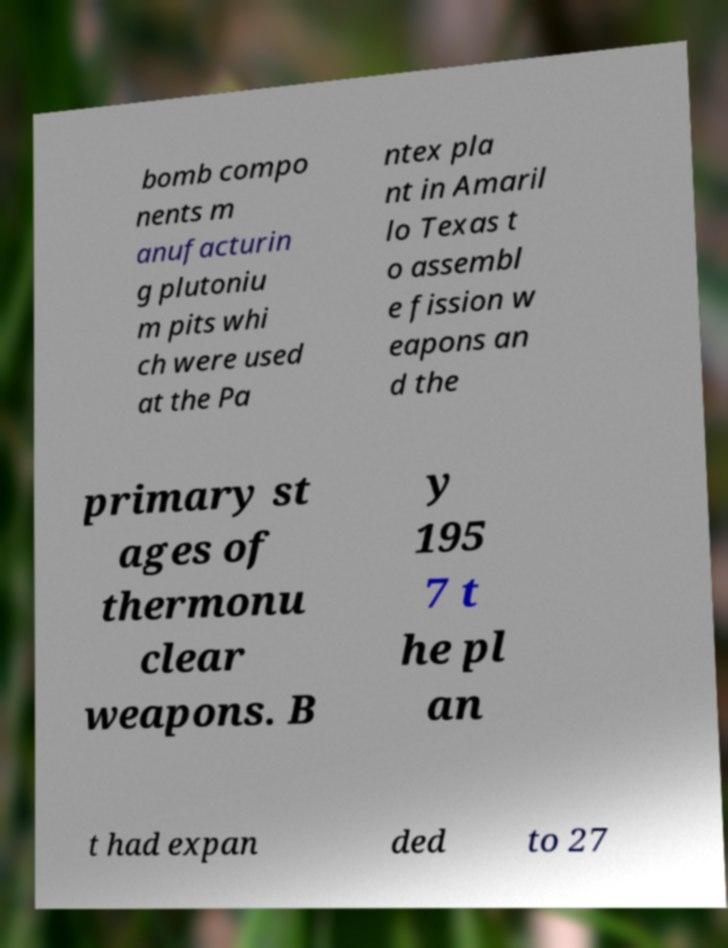For documentation purposes, I need the text within this image transcribed. Could you provide that? bomb compo nents m anufacturin g plutoniu m pits whi ch were used at the Pa ntex pla nt in Amaril lo Texas t o assembl e fission w eapons an d the primary st ages of thermonu clear weapons. B y 195 7 t he pl an t had expan ded to 27 